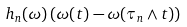<formula> <loc_0><loc_0><loc_500><loc_500>h _ { n } ( \omega ) \left ( \omega ( t ) - \omega ( \tau _ { n } \wedge t ) \right )</formula> 